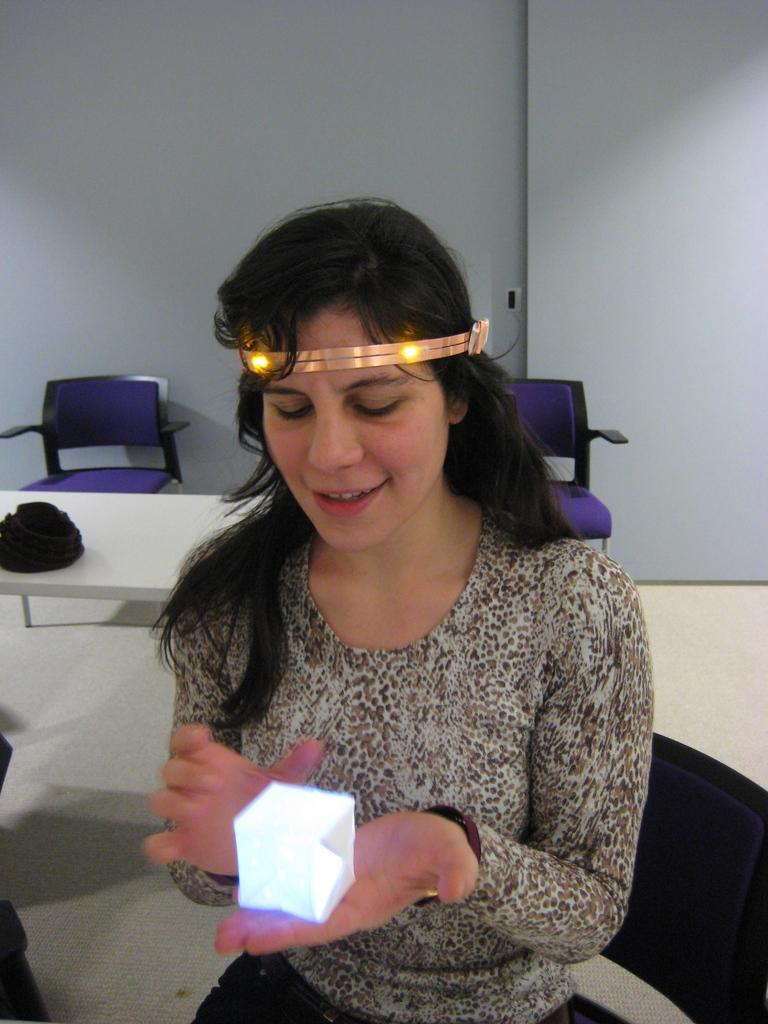Who is present in the image? There is a woman in the image. What is the woman holding in the image? The woman is holding an object, which is a chair. What type of vessel is the woman using to play volleyball in the image? There is no vessel or volleyball present in the image. The woman is holding a chair, not a vessel or volleyball. 